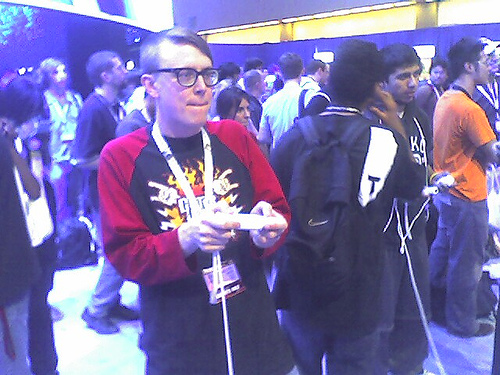Identify and read out the text in this image. T Kg 4 